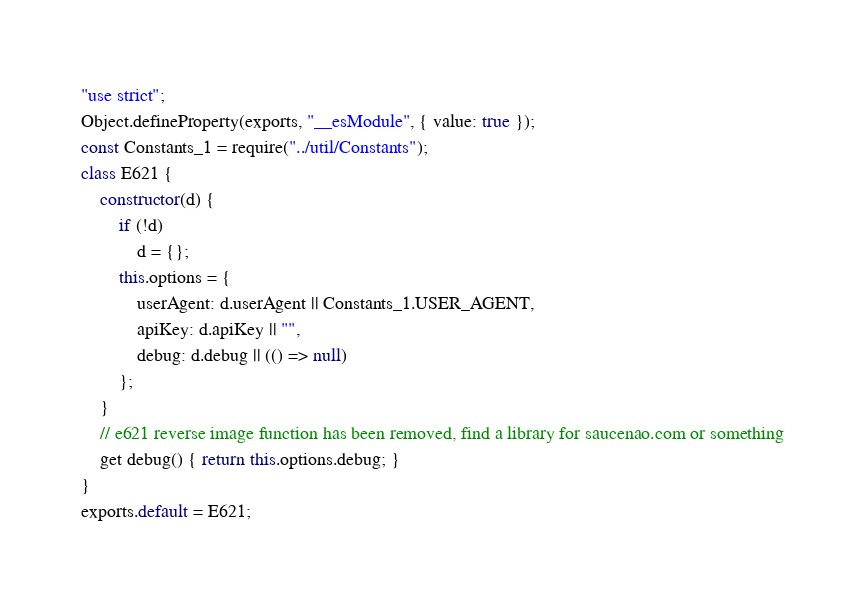Convert code to text. <code><loc_0><loc_0><loc_500><loc_500><_JavaScript_>"use strict";
Object.defineProperty(exports, "__esModule", { value: true });
const Constants_1 = require("../util/Constants");
class E621 {
    constructor(d) {
        if (!d)
            d = {};
        this.options = {
            userAgent: d.userAgent || Constants_1.USER_AGENT,
            apiKey: d.apiKey || "",
            debug: d.debug || (() => null)
        };
    }
    // e621 reverse image function has been removed, find a library for saucenao.com or something
    get debug() { return this.options.debug; }
}
exports.default = E621;
</code> 